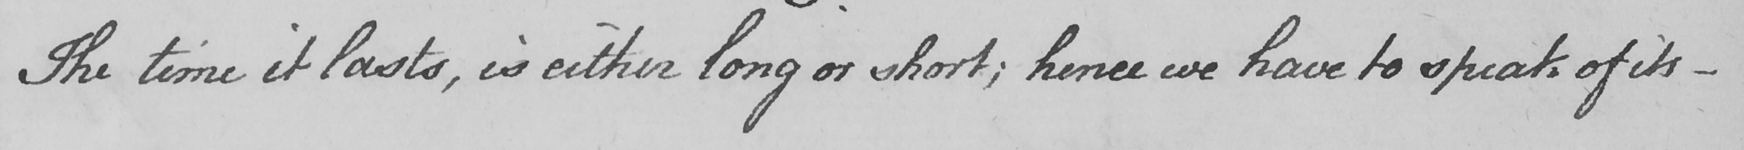Can you tell me what this handwritten text says? The time it lasts , is either long or short ; hence we have to speak of its  _ 